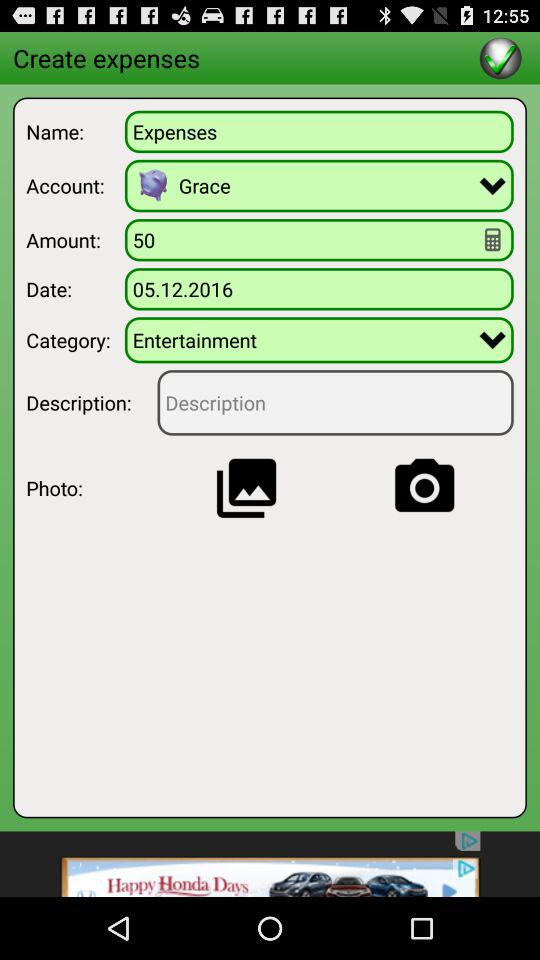What date is displayed on the screen? The date is 05.12.2016. 